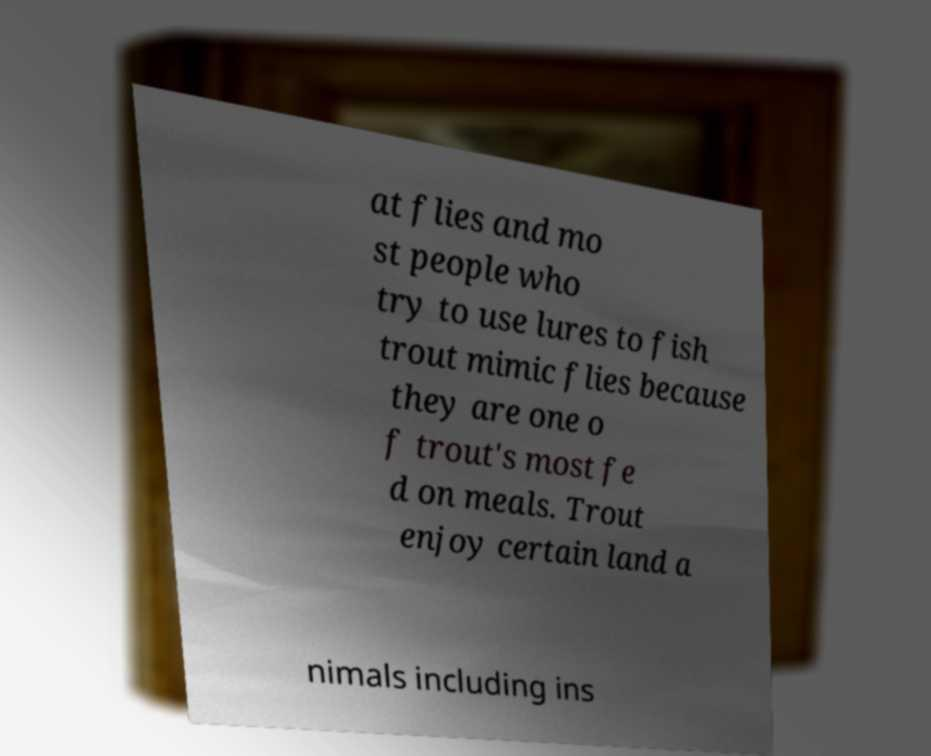Could you assist in decoding the text presented in this image and type it out clearly? at flies and mo st people who try to use lures to fish trout mimic flies because they are one o f trout's most fe d on meals. Trout enjoy certain land a nimals including ins 